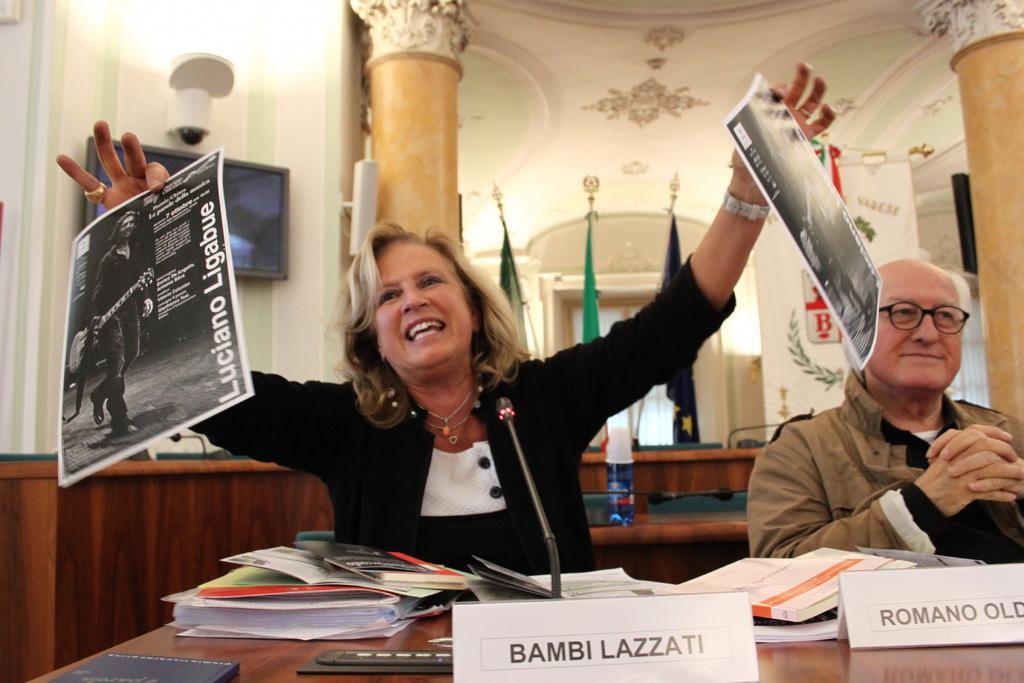How would you summarize this image in a sentence or two? In this image we can see a lady holding posters. Beside her there is a person sitting wearing jacket. In front of them there is a table on which there are books, mics and name boards. In the background of the image there are flags, pillars, wall, TV and camera. 